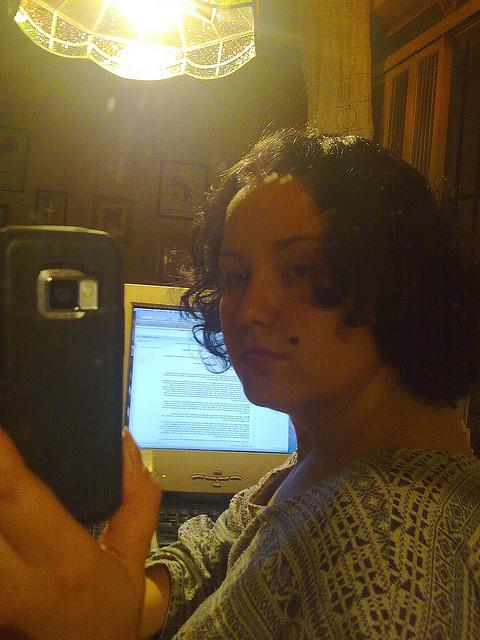What is on the woman's lip who is holding the camera in front of the computer? mole 